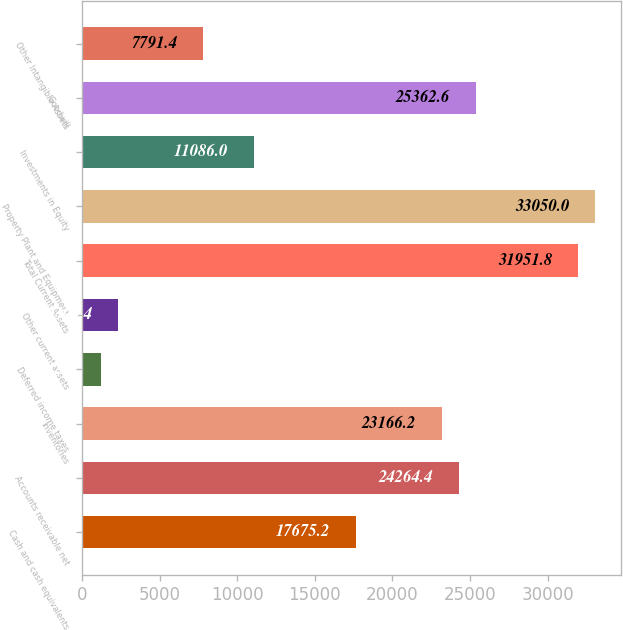Convert chart to OTSL. <chart><loc_0><loc_0><loc_500><loc_500><bar_chart><fcel>Cash and cash equivalents<fcel>Accounts receivable net<fcel>Inventories<fcel>Deferred income taxes<fcel>Other current assets<fcel>Total Current Assets<fcel>Property Plant and Equipment<fcel>Investments in Equity<fcel>Goodwill<fcel>Other Intangible Assets<nl><fcel>17675.2<fcel>24264.4<fcel>23166.2<fcel>1202.2<fcel>2300.4<fcel>31951.8<fcel>33050<fcel>11086<fcel>25362.6<fcel>7791.4<nl></chart> 